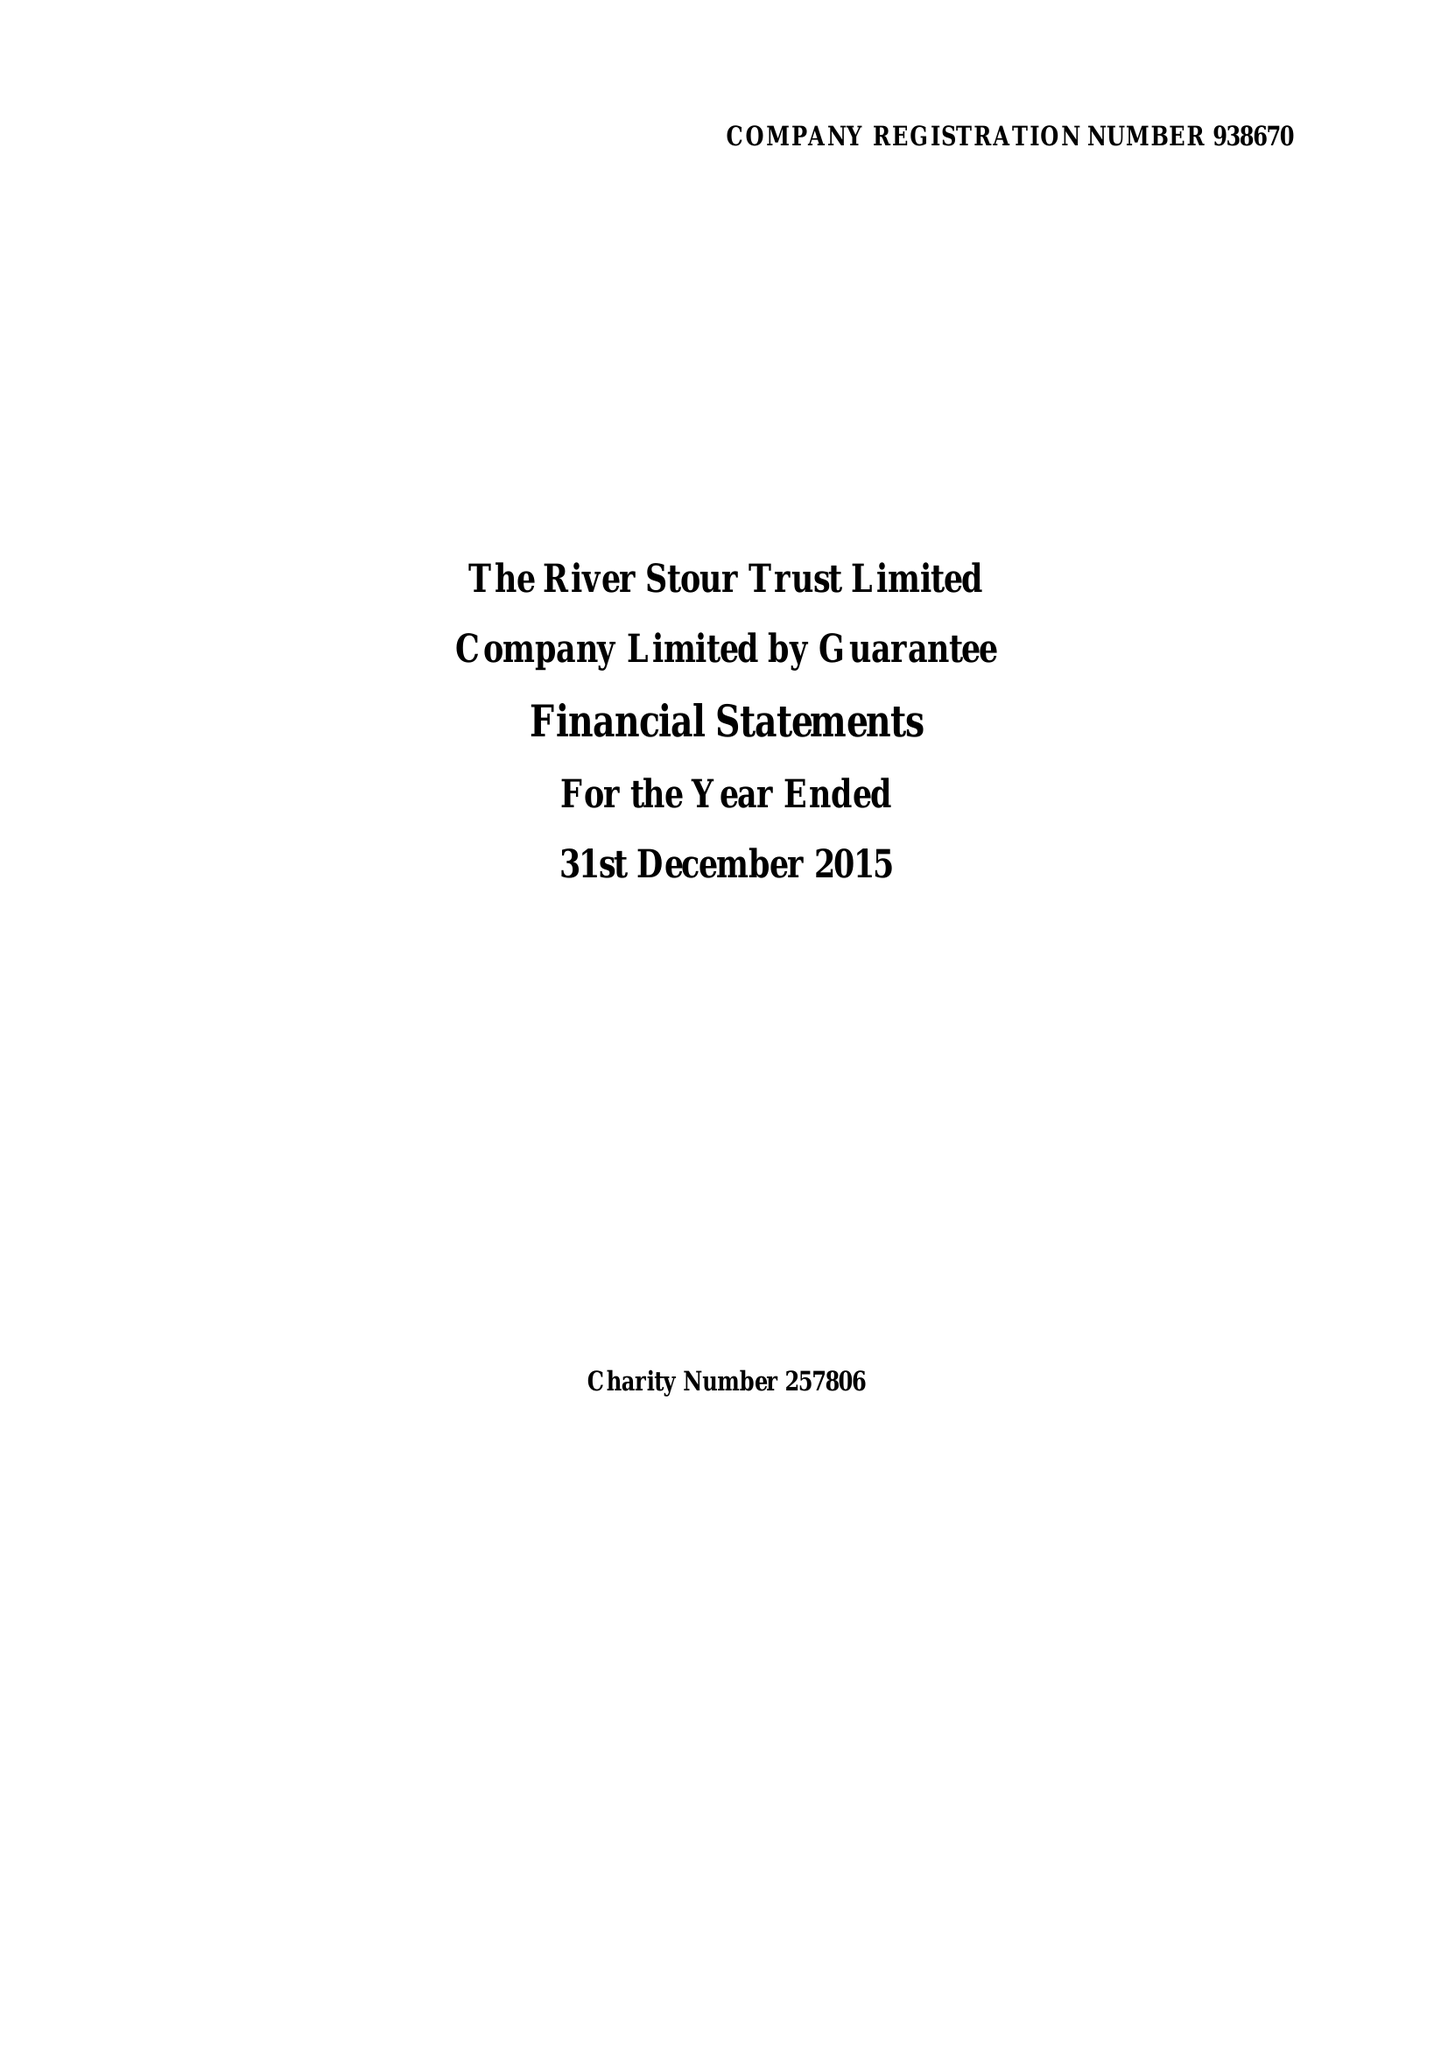What is the value for the address__postcode?
Answer the question using a single word or phrase. CO10 2AN 